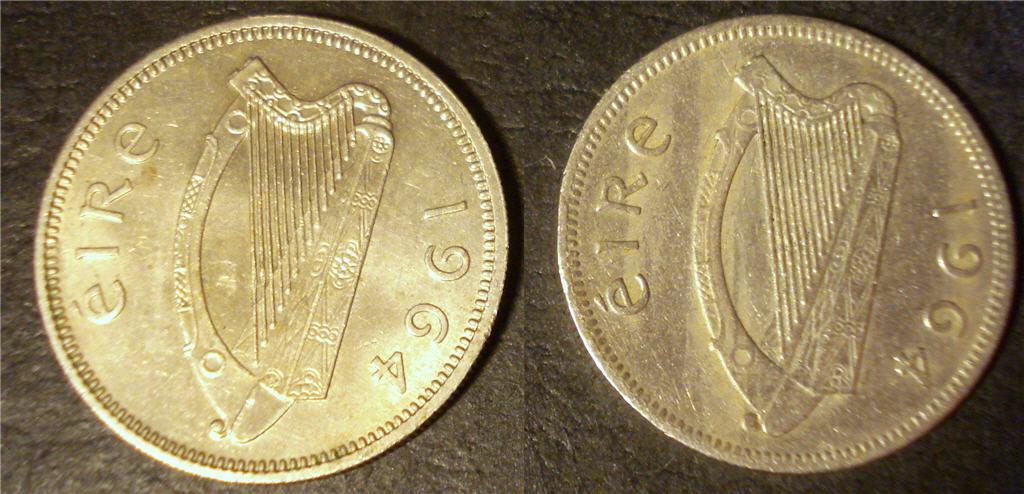Provide a one-sentence caption for the provided image. The old irish coins shown were made in 1964. 